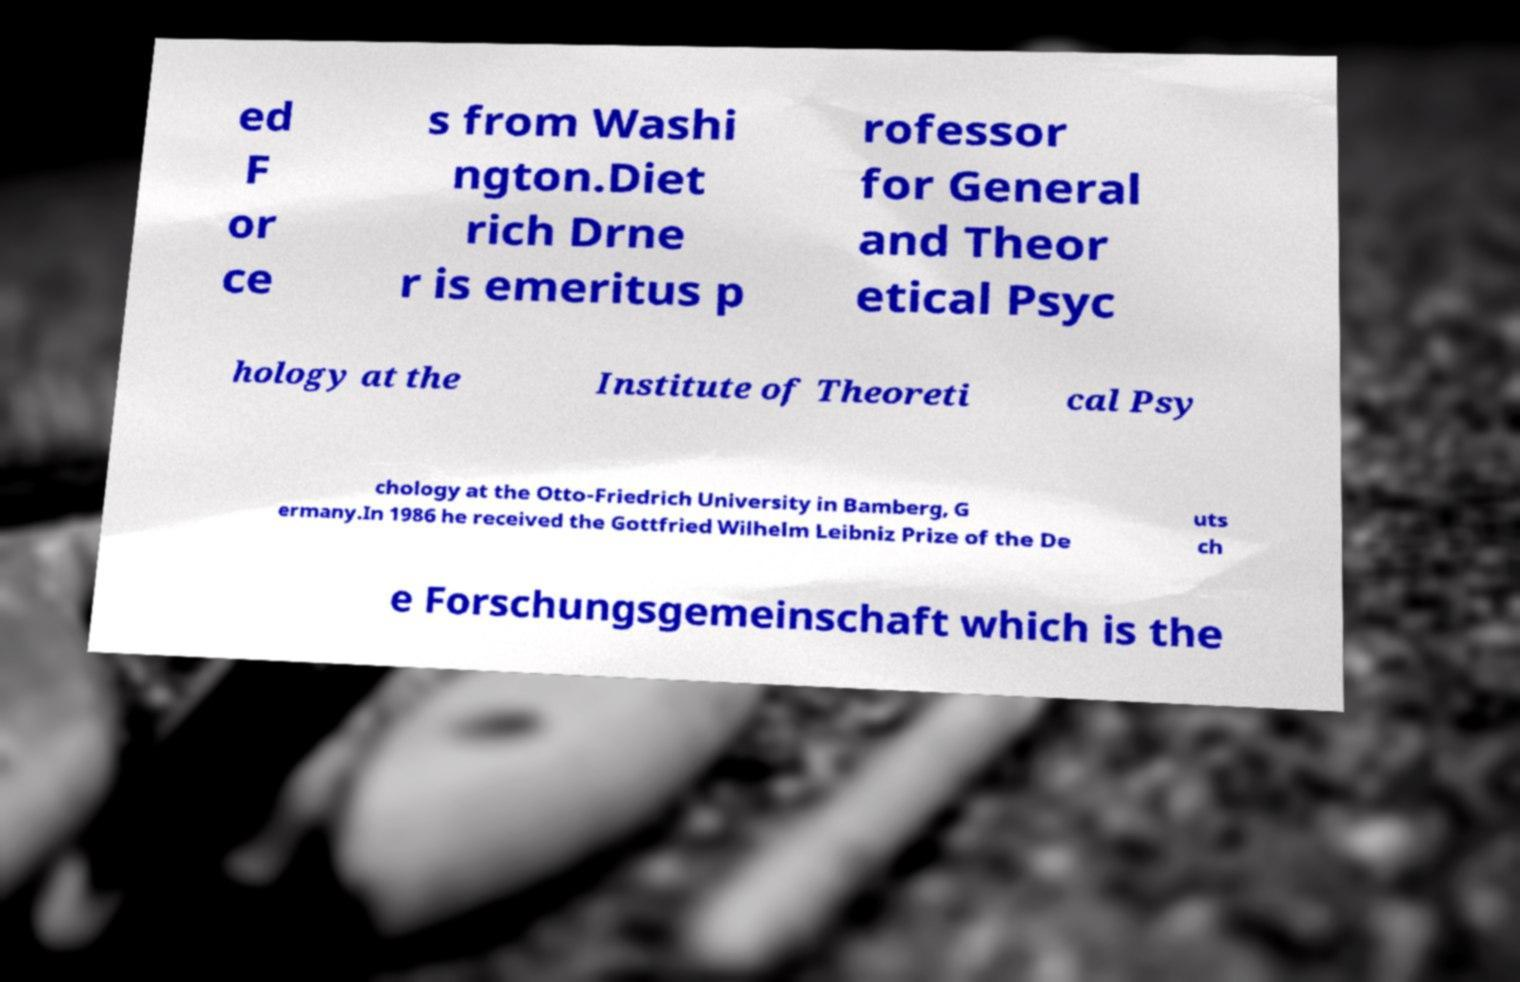Could you extract and type out the text from this image? ed F or ce s from Washi ngton.Diet rich Drne r is emeritus p rofessor for General and Theor etical Psyc hology at the Institute of Theoreti cal Psy chology at the Otto-Friedrich University in Bamberg, G ermany.In 1986 he received the Gottfried Wilhelm Leibniz Prize of the De uts ch e Forschungsgemeinschaft which is the 